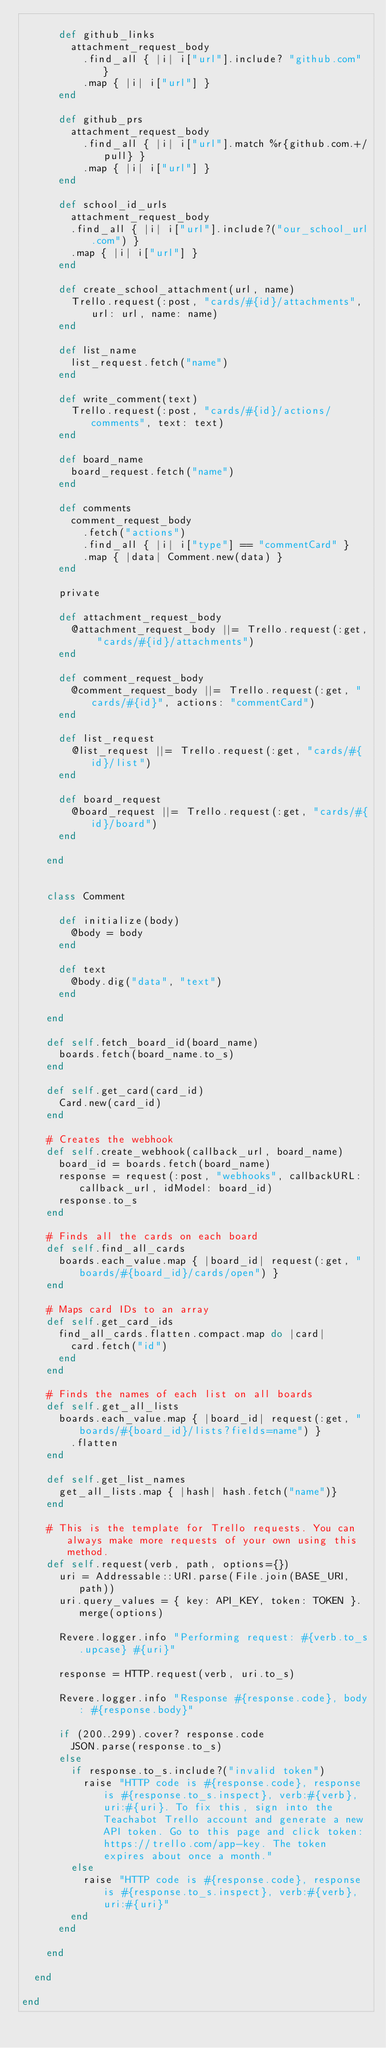<code> <loc_0><loc_0><loc_500><loc_500><_Ruby_>
      def github_links
        attachment_request_body
          .find_all { |i| i["url"].include? "github.com" }
          .map { |i| i["url"] }
      end

      def github_prs
        attachment_request_body
          .find_all { |i| i["url"].match %r{github.com.+/pull} }
          .map { |i| i["url"] }
      end

      def school_id_urls
        attachment_request_body
        .find_all { |i| i["url"].include?("our_school_url.com") }
        .map { |i| i["url"] }
      end

      def create_school_attachment(url, name)
        Trello.request(:post, "cards/#{id}/attachments", url: url, name: name)
      end

      def list_name
        list_request.fetch("name")
      end

      def write_comment(text)
        Trello.request(:post, "cards/#{id}/actions/comments", text: text)
      end

      def board_name
        board_request.fetch("name")
      end

      def comments
        comment_request_body
          .fetch("actions")
          .find_all { |i| i["type"] == "commentCard" }
          .map { |data| Comment.new(data) }
      end

      private

      def attachment_request_body
        @attachment_request_body ||= Trello.request(:get, "cards/#{id}/attachments")
      end

      def comment_request_body
        @comment_request_body ||= Trello.request(:get, "cards/#{id}", actions: "commentCard")
      end

      def list_request
        @list_request ||= Trello.request(:get, "cards/#{id}/list")
      end

      def board_request
        @board_request ||= Trello.request(:get, "cards/#{id}/board")
      end

    end


    class Comment

      def initialize(body)
        @body = body
      end

      def text
        @body.dig("data", "text")
      end

    end

    def self.fetch_board_id(board_name)
      boards.fetch(board_name.to_s)
    end

    def self.get_card(card_id)
      Card.new(card_id)
    end

    # Creates the webhook
    def self.create_webhook(callback_url, board_name)
      board_id = boards.fetch(board_name)
      response = request(:post, "webhooks", callbackURL: callback_url, idModel: board_id)
      response.to_s
    end

    # Finds all the cards on each board
    def self.find_all_cards
      boards.each_value.map { |board_id| request(:get, "boards/#{board_id}/cards/open") }
    end

    # Maps card IDs to an array
    def self.get_card_ids
      find_all_cards.flatten.compact.map do |card|
        card.fetch("id")
      end
    end

    # Finds the names of each list on all boards
    def self.get_all_lists
      boards.each_value.map { |board_id| request(:get, "boards/#{board_id}/lists?fields=name") }
        .flatten
    end

    def self.get_list_names
      get_all_lists.map { |hash| hash.fetch("name")}
    end

    # This is the template for Trello requests. You can always make more requests of your own using this method.
    def self.request(verb, path, options={})
      uri = Addressable::URI.parse(File.join(BASE_URI, path))
      uri.query_values = { key: API_KEY, token: TOKEN }.merge(options)

      Revere.logger.info "Performing request: #{verb.to_s.upcase} #{uri}"

      response = HTTP.request(verb, uri.to_s)

      Revere.logger.info "Response #{response.code}, body: #{response.body}"

      if (200..299).cover? response.code
        JSON.parse(response.to_s)
      else
        if response.to_s.include?("invalid token")
          raise "HTTP code is #{response.code}, response is #{response.to_s.inspect}, verb:#{verb}, uri:#{uri}. To fix this, sign into the Teachabot Trello account and generate a new API token. Go to this page and click token: https://trello.com/app-key. The token expires about once a month."
        else
          raise "HTTP code is #{response.code}, response is #{response.to_s.inspect}, verb:#{verb}, uri:#{uri}"
        end
      end

    end

  end

end
</code> 